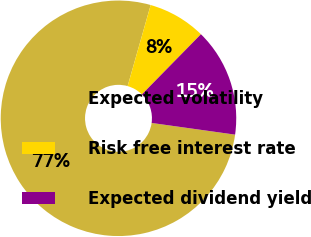Convert chart. <chart><loc_0><loc_0><loc_500><loc_500><pie_chart><fcel>Expected volatility<fcel>Risk free interest rate<fcel>Expected dividend yield<nl><fcel>77.19%<fcel>7.94%<fcel>14.87%<nl></chart> 